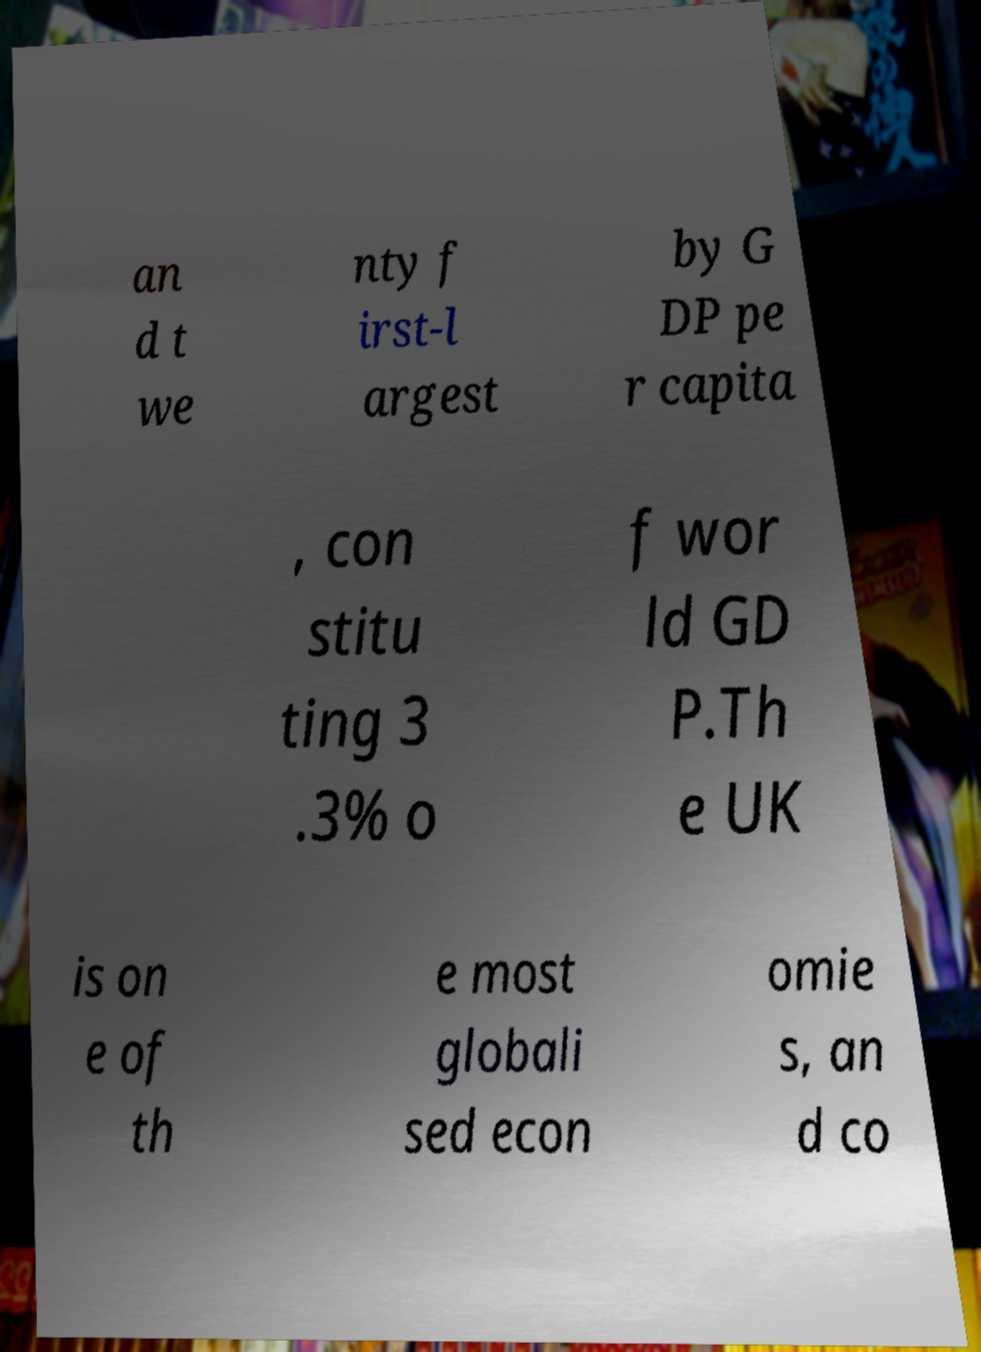Could you assist in decoding the text presented in this image and type it out clearly? an d t we nty f irst-l argest by G DP pe r capita , con stitu ting 3 .3% o f wor ld GD P.Th e UK is on e of th e most globali sed econ omie s, an d co 